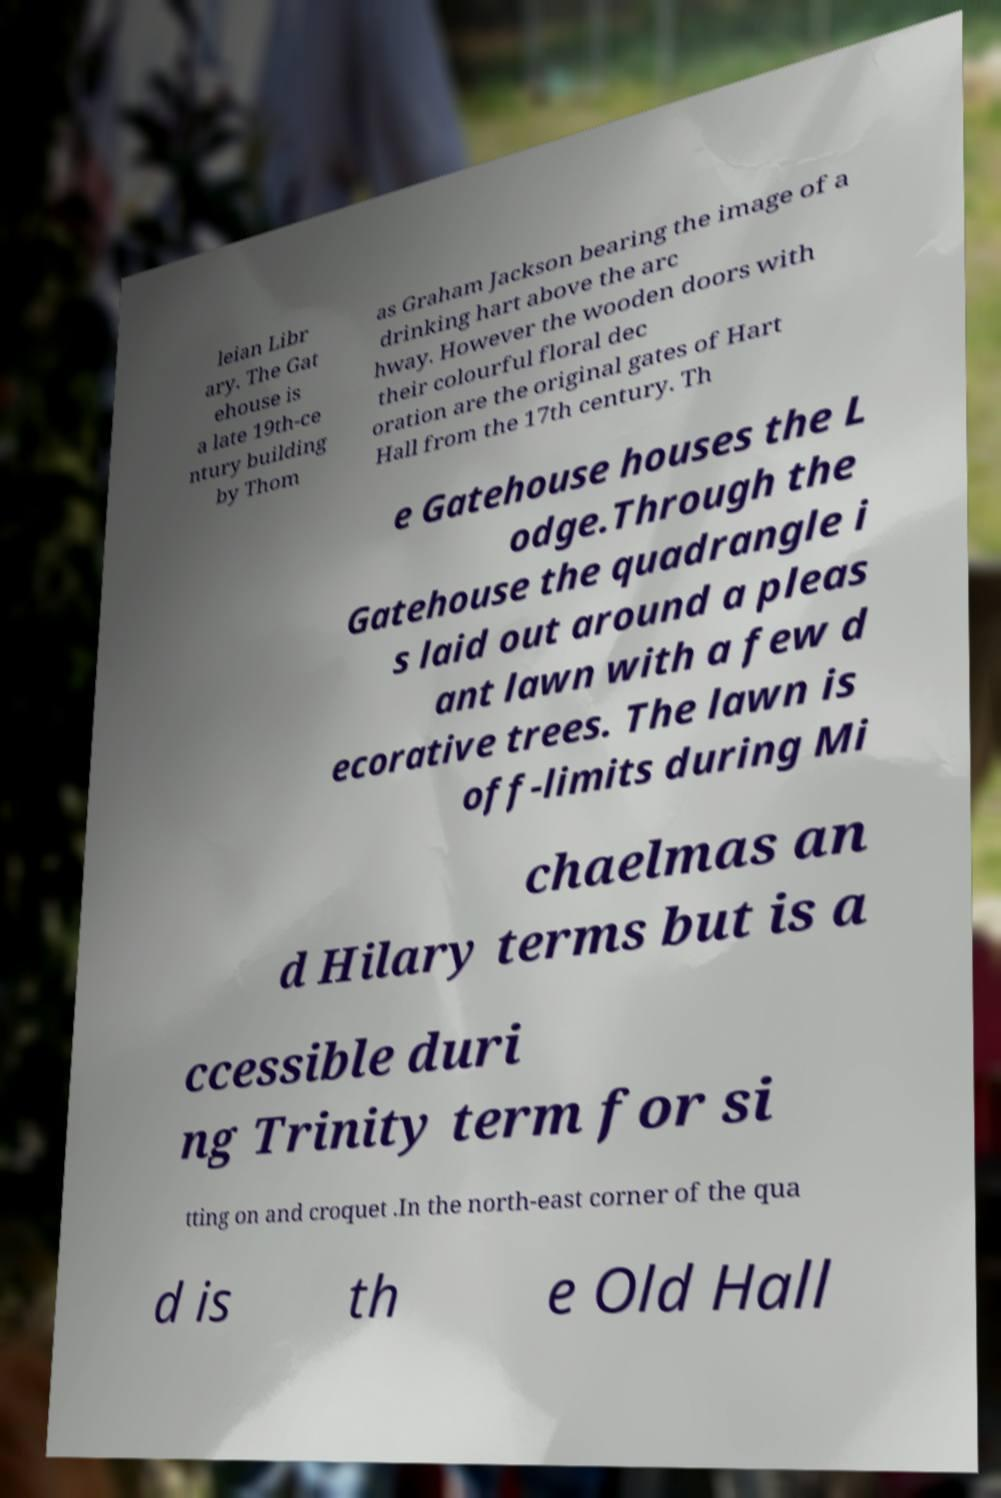I need the written content from this picture converted into text. Can you do that? leian Libr ary. The Gat ehouse is a late 19th-ce ntury building by Thom as Graham Jackson bearing the image of a drinking hart above the arc hway. However the wooden doors with their colourful floral dec oration are the original gates of Hart Hall from the 17th century. Th e Gatehouse houses the L odge.Through the Gatehouse the quadrangle i s laid out around a pleas ant lawn with a few d ecorative trees. The lawn is off-limits during Mi chaelmas an d Hilary terms but is a ccessible duri ng Trinity term for si tting on and croquet .In the north-east corner of the qua d is th e Old Hall 